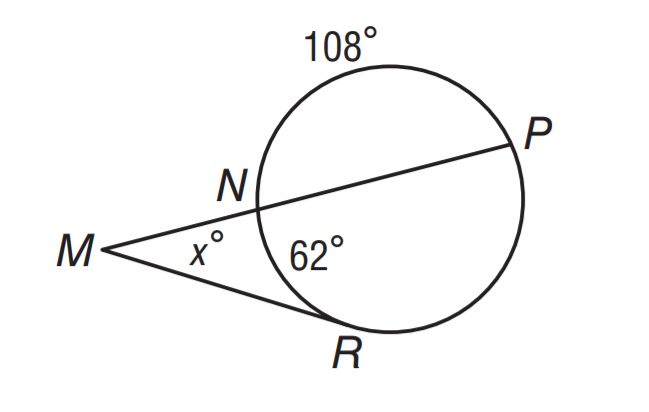Answer the mathemtical geometry problem and directly provide the correct option letter.
Question: What is the value of x if m \widehat N R = 62 and m \widehat N P = 108?
Choices: A: 23 B: 31 C: 64 D: 128 C 